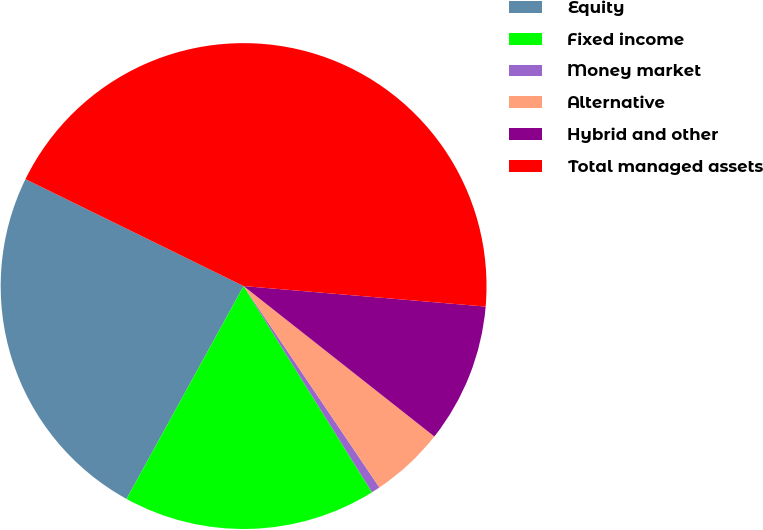<chart> <loc_0><loc_0><loc_500><loc_500><pie_chart><fcel>Equity<fcel>Fixed income<fcel>Money market<fcel>Alternative<fcel>Hybrid and other<fcel>Total managed assets<nl><fcel>24.25%<fcel>16.86%<fcel>0.58%<fcel>4.93%<fcel>9.28%<fcel>44.09%<nl></chart> 